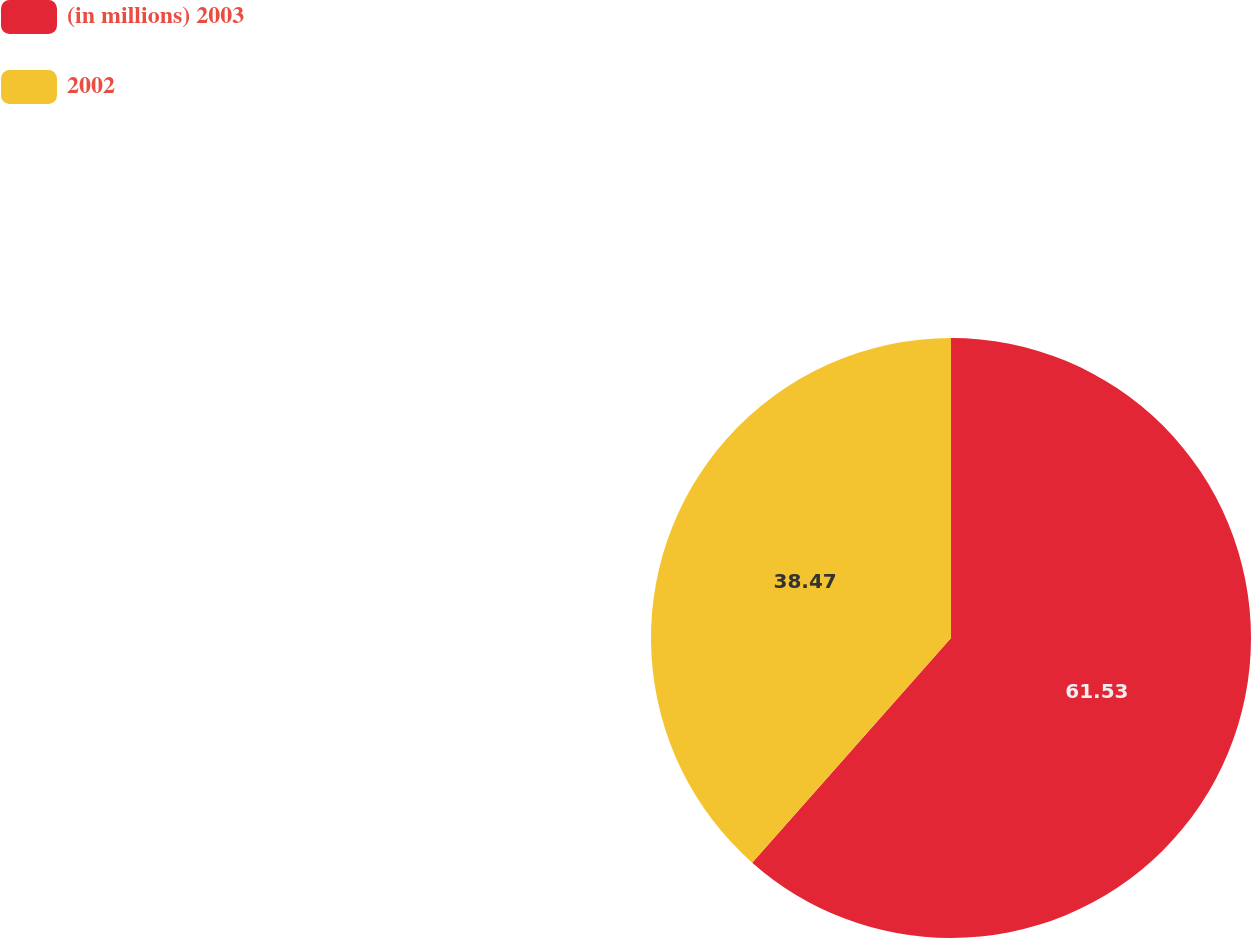Convert chart to OTSL. <chart><loc_0><loc_0><loc_500><loc_500><pie_chart><fcel>(in millions) 2003<fcel>2002<nl><fcel>61.53%<fcel>38.47%<nl></chart> 